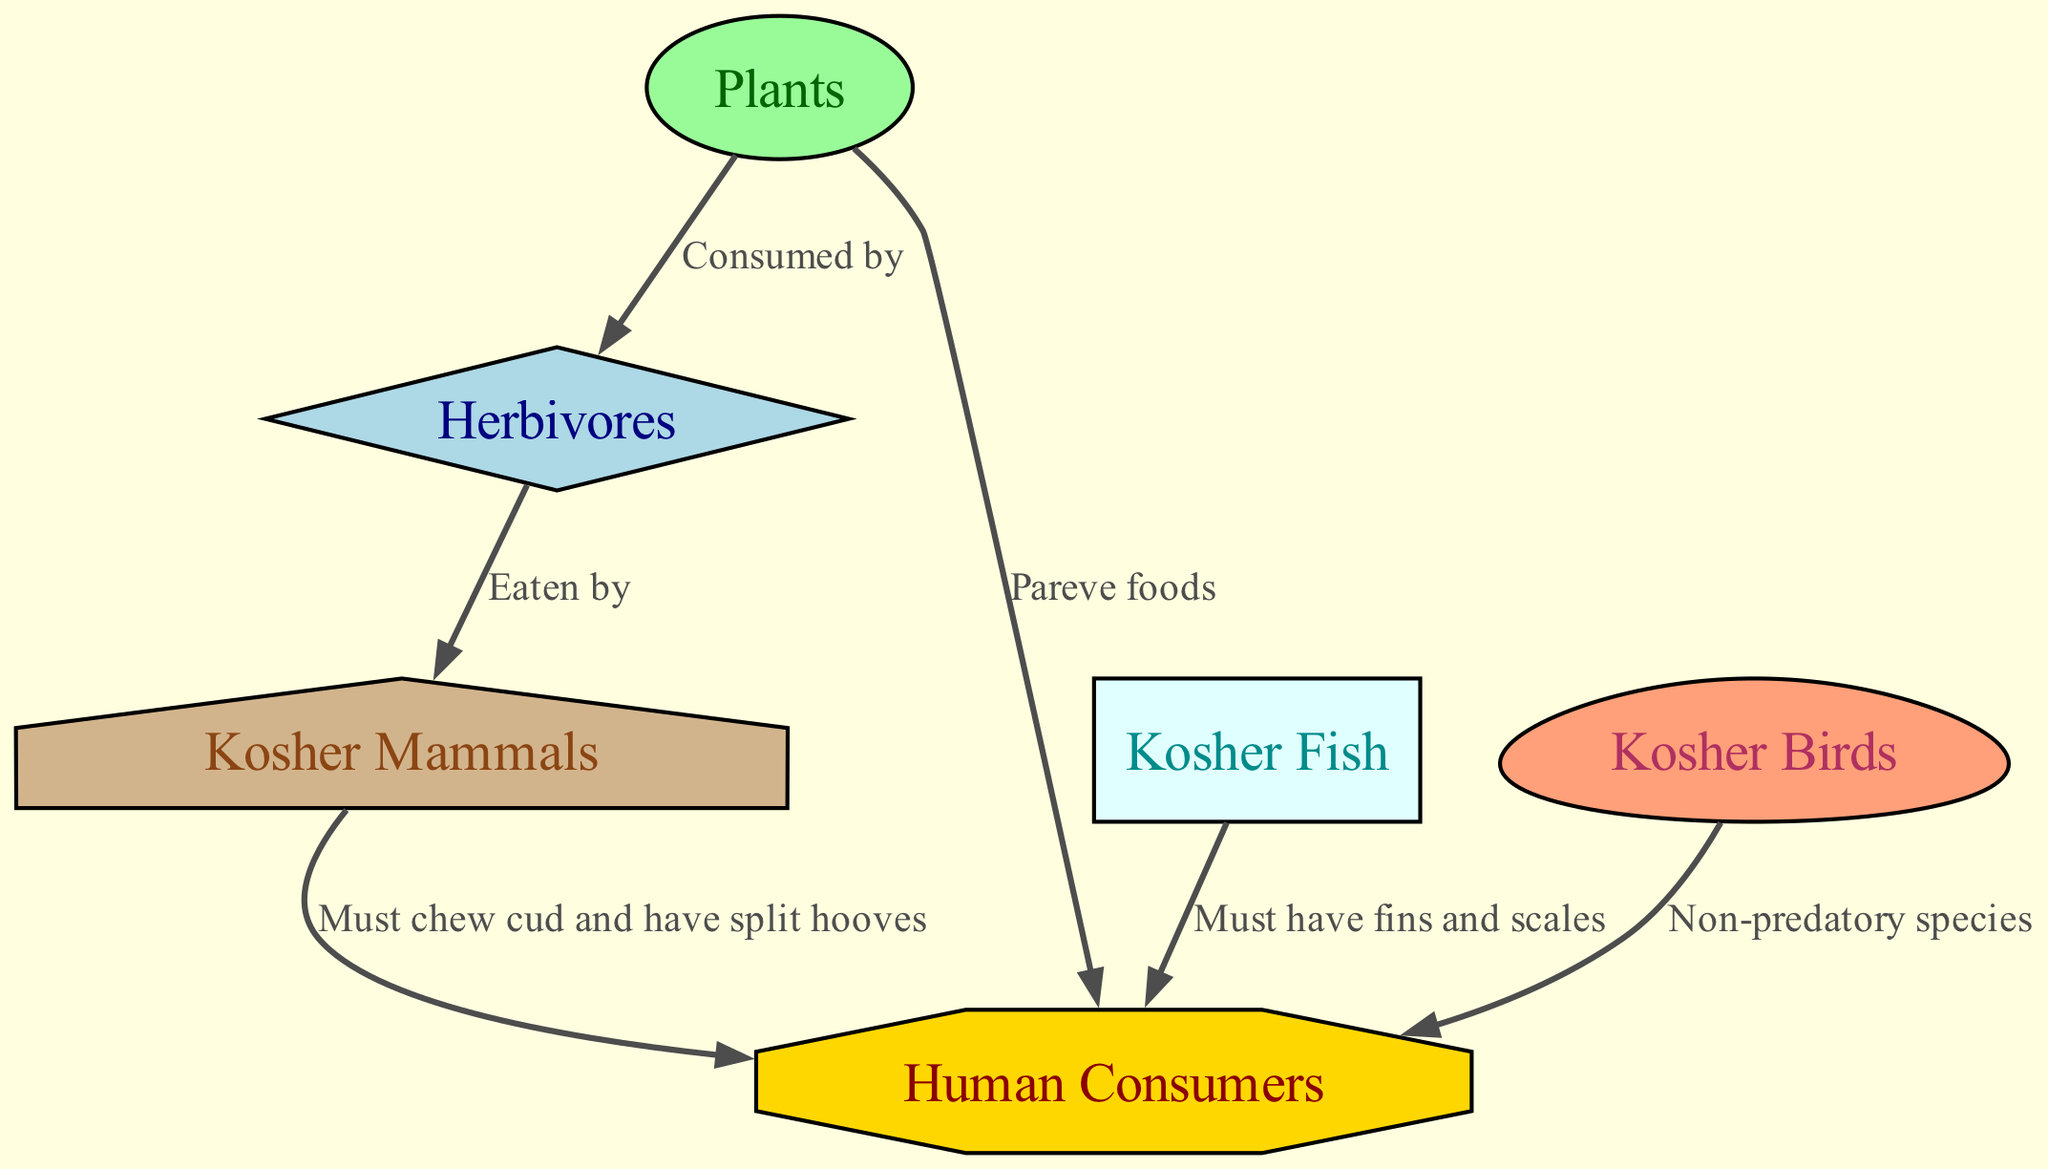What is the total number of nodes in the food chain? The diagram lists six distinct entities as nodes: Plants, Herbivores, Kosher Fish, Kosher Birds, Kosher Mammals, and Human Consumers. Counting these, we find a total of six nodes.
Answer: 6 How many edges are present in the diagram? The diagram contains six connections (edges) between nodes, depicting relationships such as consumption and dietary requirements. Counting these, we confirm that there are six edges.
Answer: 6 Which node is directly connected to Plants? Looking at the edges, we see that Plants is connected to Herbivores and Human Consumers. Both edges indicate interaction from Plants, but since the question asks for the first observed connection, Herbivores is the immediate one.
Answer: Herbivores What must kosher fish have to be considered acceptable for consumption? The diagram specifies that kosher fish must have fins and scales, indicating a requirement for their acceptance in kosher dietary laws.
Answer: Fins and scales Which type of mammal can be consumed according to kosher practice? The kosher dietary laws stipulate that for mammals to be consumed, they must chew cud and have split hooves. Referring to the diagram, this narrows down the types of mammals to those which meet these criteria.
Answer: Chew cud and have split hooves Which connection describes the relationship between Herbivores and Kosher Mammals? The diagram shows the edge that indicates 'Eaten by' from Herbivores to Kosher Mammals, suggesting that these mammals derive sustenance from herbivorous animals in a food chain context.
Answer: Eaten by What category do kosher birds fall under? The diagram categorizes kosher birds specifically as 'Non-predatory species,' which is designated as the dietary guideline for what can be eaten from avian life forms according to kosher laws.
Answer: Non-predatory species Which node represents human consumers in the food chain? Upon examining the nodes, the one denoted as 'Human Consumers' is represented in an octagonal shape and is highlighted as the end consumer in this food chain diagram.
Answer: Human Consumers 